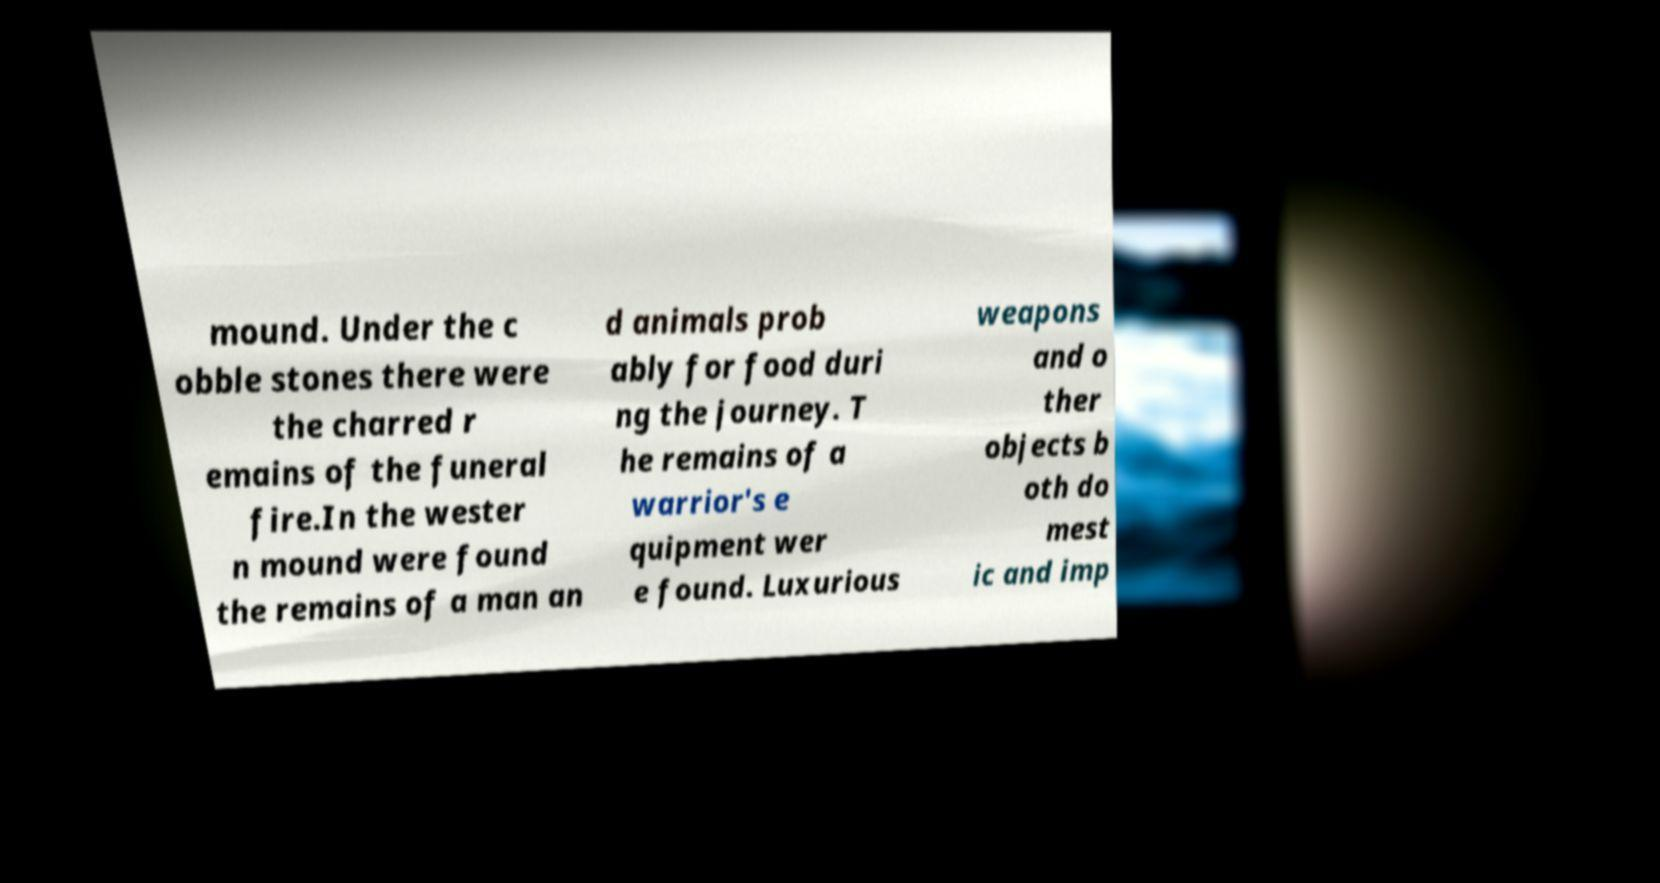Can you accurately transcribe the text from the provided image for me? mound. Under the c obble stones there were the charred r emains of the funeral fire.In the wester n mound were found the remains of a man an d animals prob ably for food duri ng the journey. T he remains of a warrior's e quipment wer e found. Luxurious weapons and o ther objects b oth do mest ic and imp 